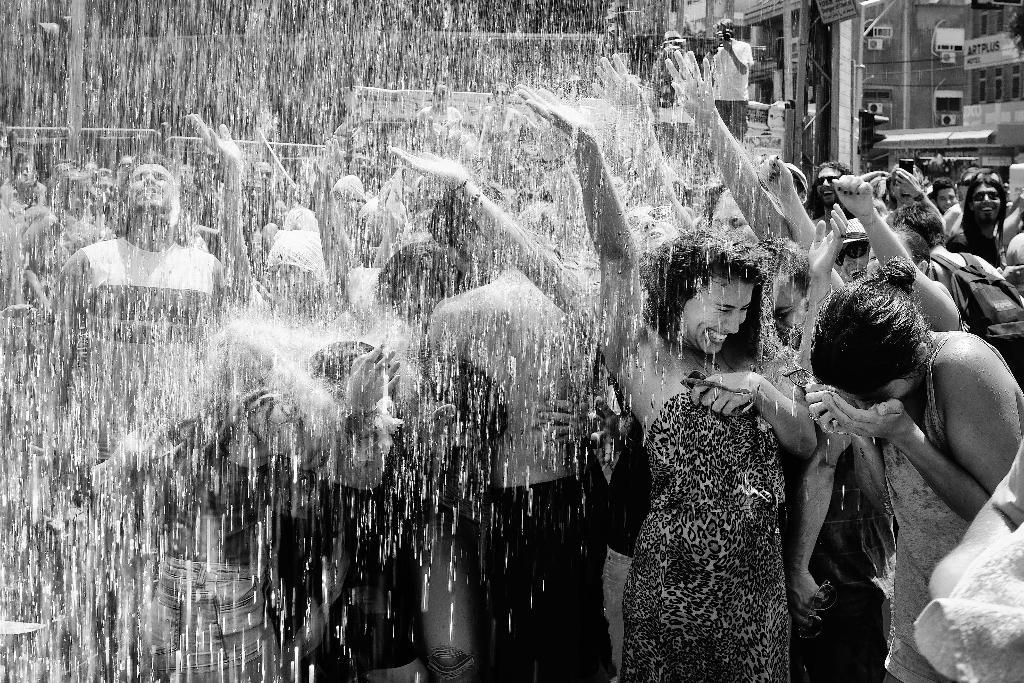How many people are in the group visible in the image? There is a group of people standing in the image, but the exact number cannot be determined from the provided facts. What can be seen in the background of the image? There are buildings and water visible in the background of the image. What is the person holding in the image? The person is holding a camera in the image. What is the color scheme of the image? The image is black and white in color. How many beams are visible in the image? There is no beam present in the image. Can you describe the crowd in the image? The image does not depict a crowd; it shows a group of people standing together. 